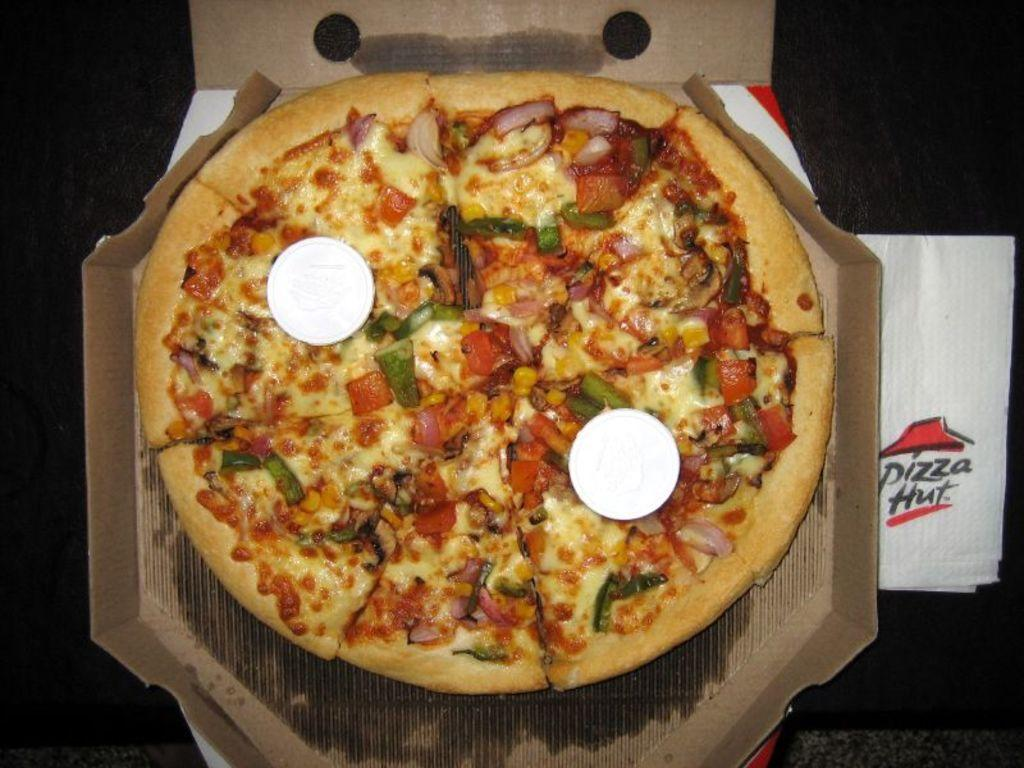What is the main piece of furniture in the image? There is a table in the image. What food item is on the table? There is a pizza on the table. What additional item can be seen on the table? There is tissue on the table. What type of representative is present in the image? There is no representative present in the image; it only features a table, pizza, and tissue. 